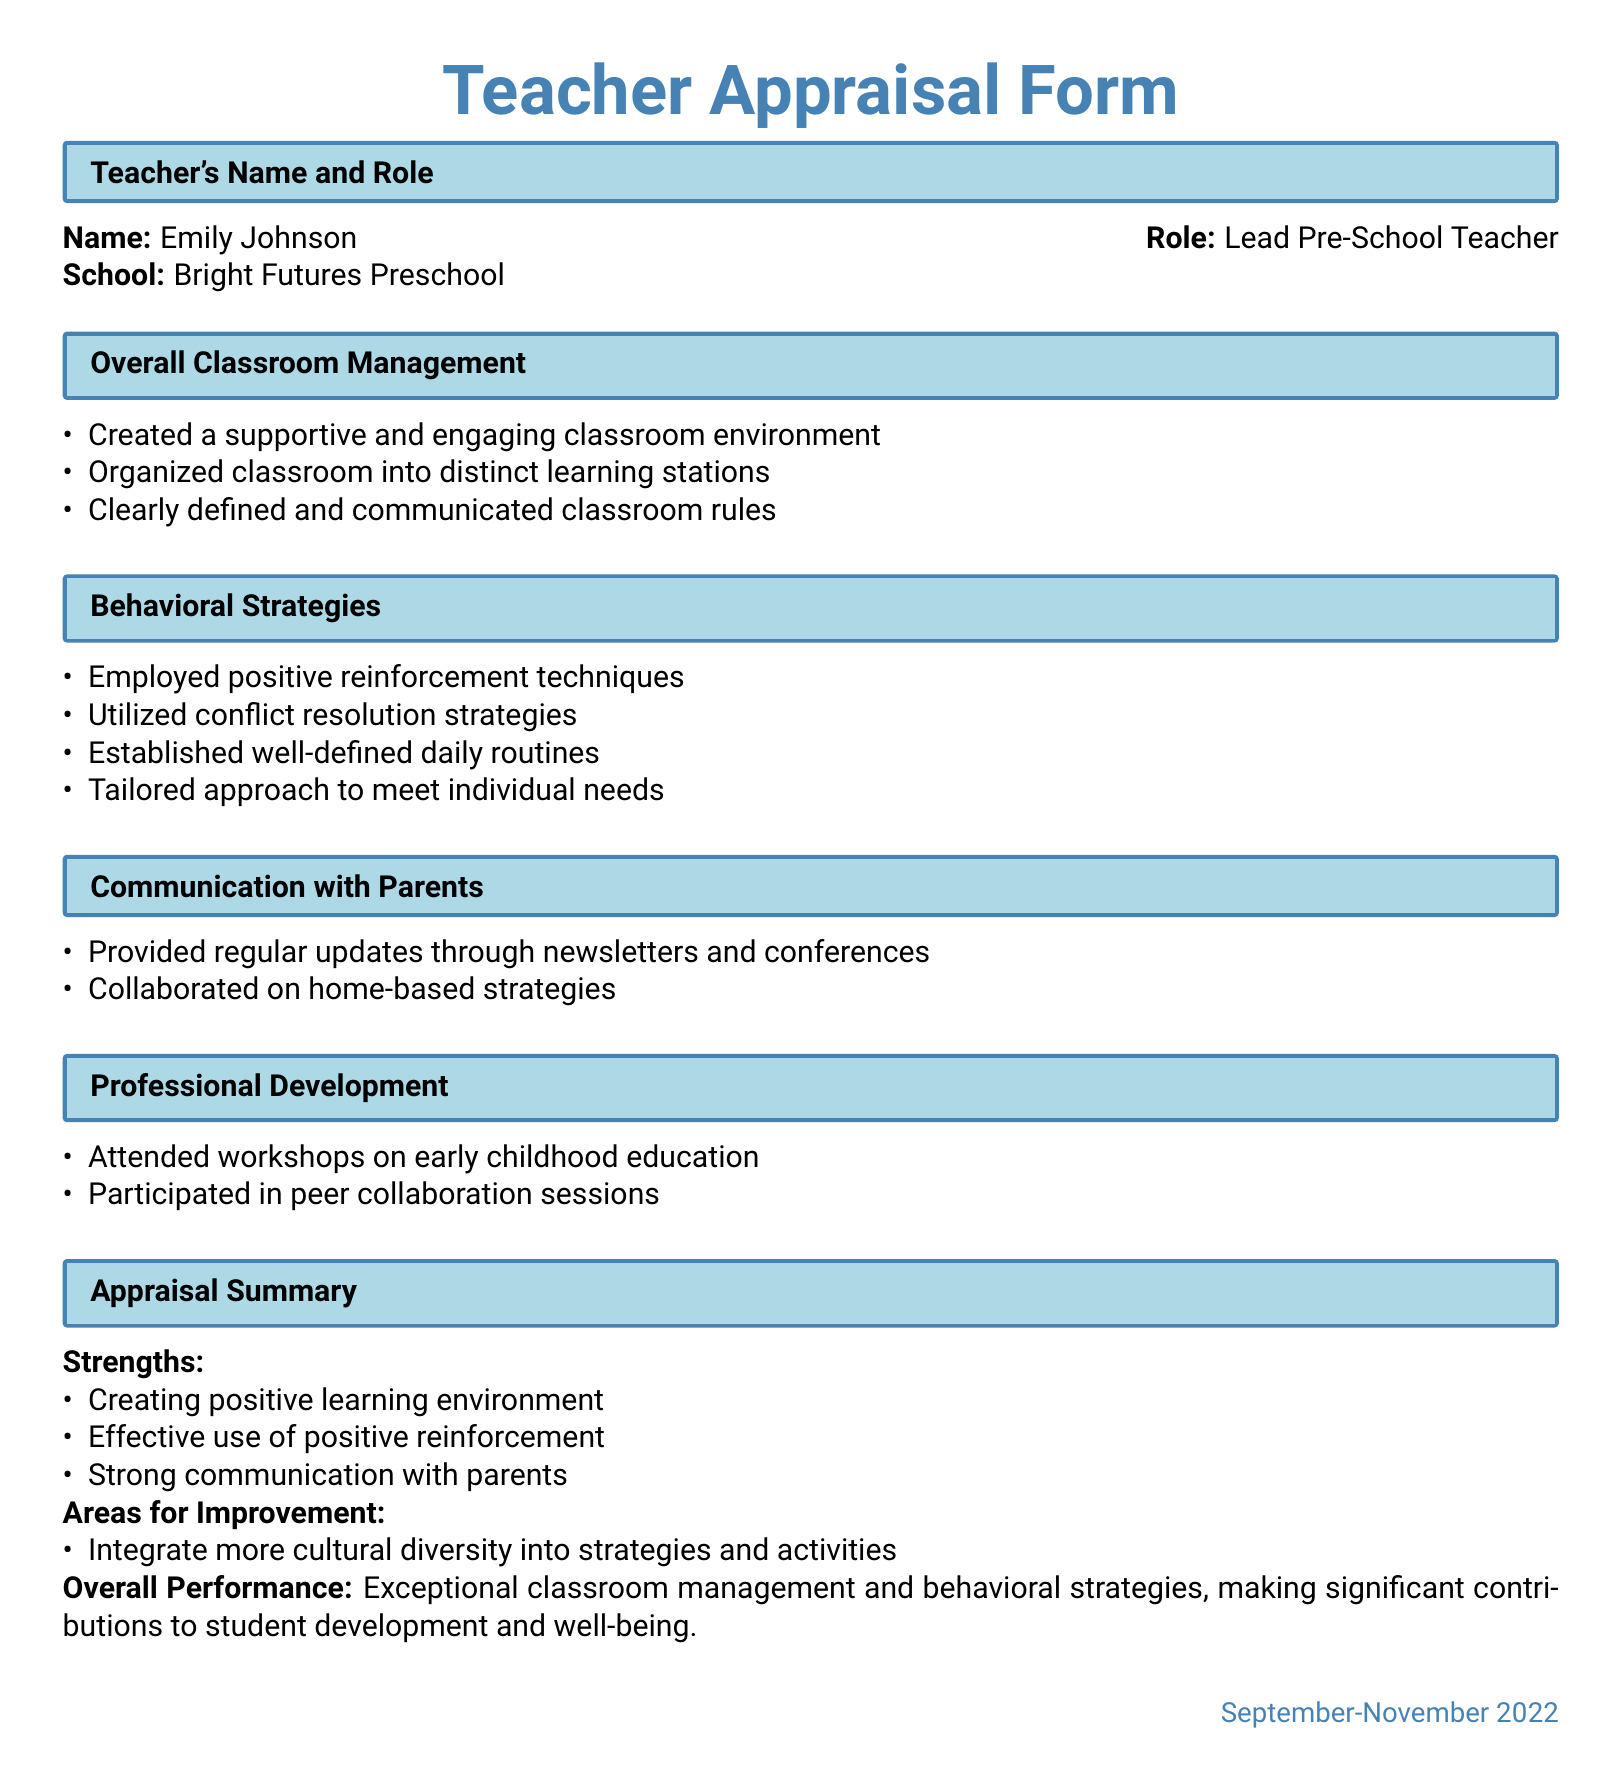What is the teacher's name? The teacher's name is provided in the section labeled "Teacher's Name and Role."
Answer: Emily Johnson What is the teacher's role? The teacher's role is specified alongside the name in the same section.
Answer: Lead Pre-School Teacher What school does the teacher work at? The school name is mentioned in the section indicating the teacher's details.
Answer: Bright Futures Preschool What are the strengths listed in the appraisal summary? The appraisal summary highlights positive attributes in a bulleted list under "Strengths."
Answer: Creating positive learning environment, Effective use of positive reinforcement, Strong communication with parents What area is suggested for improvement? The areas for improvement are detailed in the appraisal summary, indicating what the teacher could enhance.
Answer: Integrate more cultural diversity into strategies and activities How often did the teacher provide updates to parents? Regular updates are mentioned in the communication section of the document.
Answer: Regular updates What type of workshops did the teacher attend? The type of workshops is specified in the professional development section of the document.
Answer: Early childhood education What behavioral strategy was employed? The behavioral strategies utilized are listed item-by-item in the relevant section of the appraisal.
Answer: Positive reinforcement techniques What is the overall performance rating? The overall performance is summarized explicitly in the appraisal summary.
Answer: Exceptional classroom management and behavioral strategies 